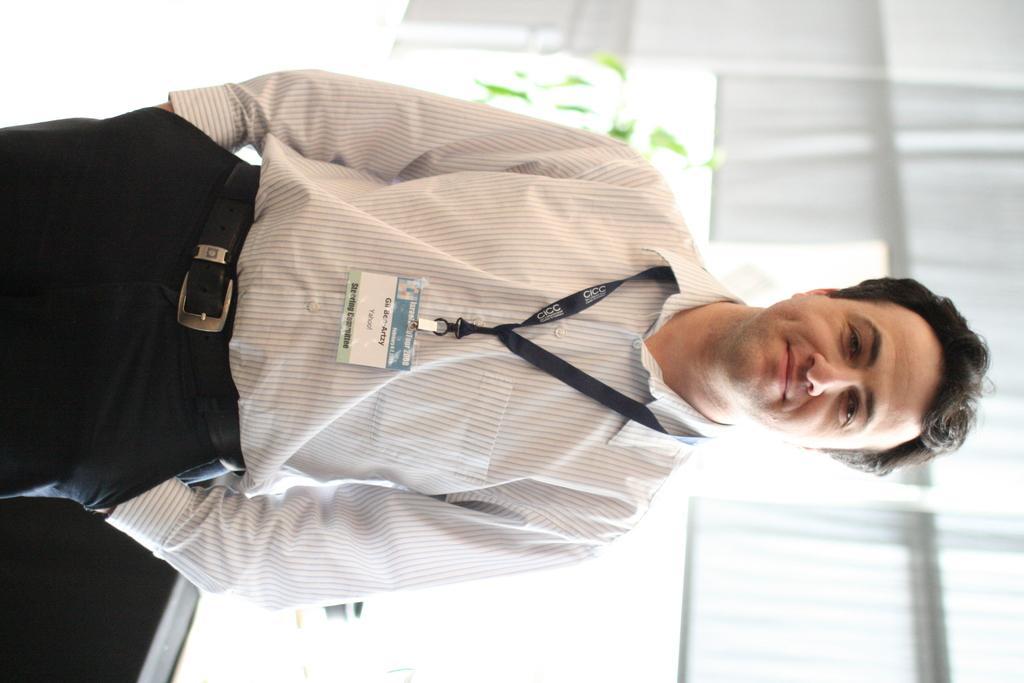Can you describe this image briefly? In this image I can see a person wearing white shirt and black pant is standing. In the background I can see few glass windows, a plant which is green in color and few window blinds. 